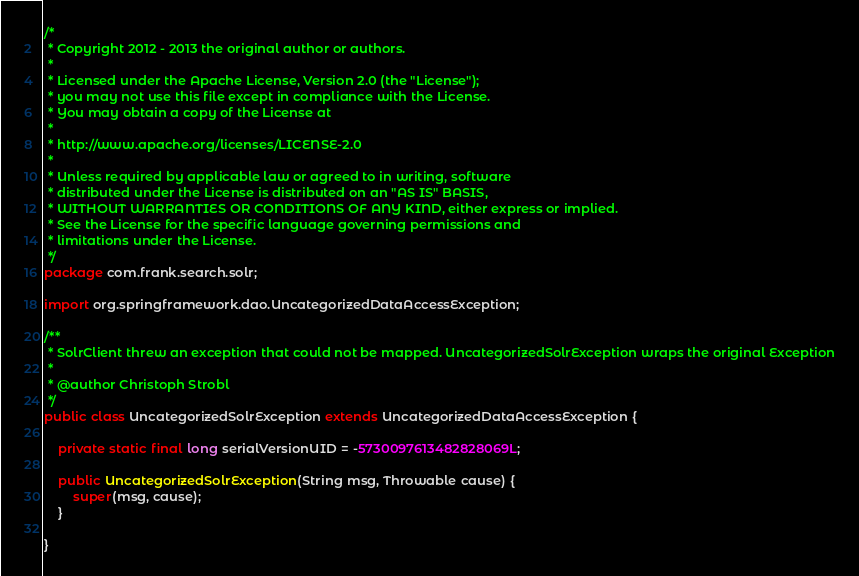<code> <loc_0><loc_0><loc_500><loc_500><_Java_>/*
 * Copyright 2012 - 2013 the original author or authors.
 *
 * Licensed under the Apache License, Version 2.0 (the "License");
 * you may not use this file except in compliance with the License.
 * You may obtain a copy of the License at
 *
 * http://www.apache.org/licenses/LICENSE-2.0
 *
 * Unless required by applicable law or agreed to in writing, software
 * distributed under the License is distributed on an "AS IS" BASIS,
 * WITHOUT WARRANTIES OR CONDITIONS OF ANY KIND, either express or implied.
 * See the License for the specific language governing permissions and
 * limitations under the License.
 */
package com.frank.search.solr;

import org.springframework.dao.UncategorizedDataAccessException;

/**
 * SolrClient threw an exception that could not be mapped. UncategorizedSolrException wraps the original Exception
 * 
 * @author Christoph Strobl
 */
public class UncategorizedSolrException extends UncategorizedDataAccessException {

	private static final long serialVersionUID = -5730097613482828069L;

	public UncategorizedSolrException(String msg, Throwable cause) {
		super(msg, cause);
	}

}
</code> 